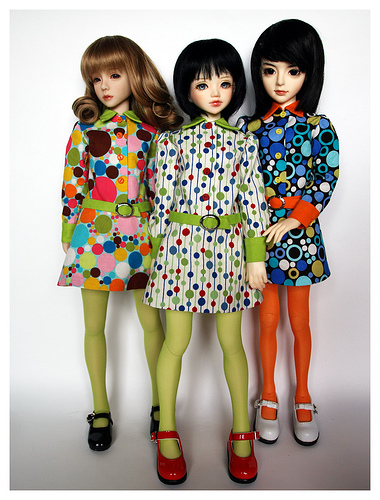<image>
Is the doll to the left of the doll? Yes. From this viewpoint, the doll is positioned to the left side relative to the doll. 